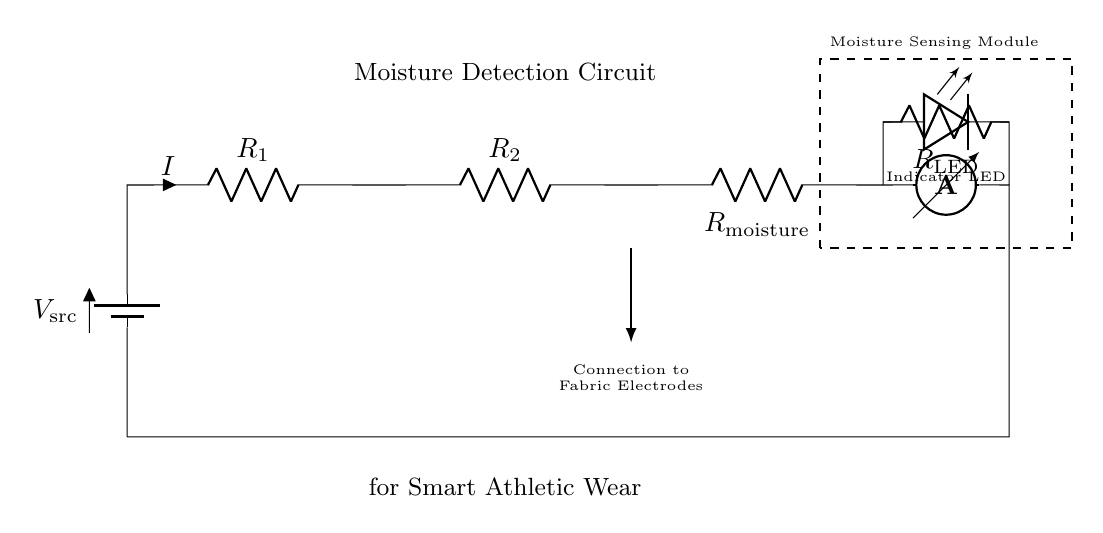What is the source voltage in this circuit? The source voltage, indicated as V_src, is typically a single value provided at the battery symbol in a schematic. It tends to be the required power supply voltage for the entire circuit.
Answer: V_src How many resistors are present in the circuit? The circuit includes three resistors labeled R1, R2, and R_moisture, which are all visible in the diagram. Each is connected in series within the circuit.
Answer: Three What is the purpose of the LED in this circuit? The LED serves as an indicator, which shows whether moisture is detected. When moisture is sensed through R_moisture, it allows current to flow, causing the LED to light up, signaling its status.
Answer: Indicator What type of connection is used to connect to the fabric electrodes? The connection to the fabric electrodes is indicated as a wire with a directional arrow, showing that it leads to the moisture sensing module and allows for the detection of moisture through the fabric.
Answer: Wire Explain how the moisture sensing module operates. The moisture sensing module operates by allowing current from the voltage source to pass through the resistors and the moisture sensor. When moisture is detected, the resistance changes, affecting the overall current flow. If a certain moisture level is reached, the current flowing through R_LED will be sufficient to turn on the Indicator LED, thus signaling that moisture has been detected. This indicates that the electronic system is monitoring the moisture content effectively.
Answer: Changes resistance and signals moisture presence What happens to the current if moisture is detected? If moisture is detected, the resistance of R_moisture decreases, which leads to an increase in current flow in the circuit due to Ohm's law, assuming the voltage remains constant. This increased current may trigger the LED to light up, providing a visual indication of moisture detection.
Answer: Increases What is the function of the ammeter in this circuit? The ammeter is used to measure the current flowing through the entire circuit. It provides information about how much current is being used, which can indicate the moisture level by correlating current changes with moisture presence.
Answer: Measure current 